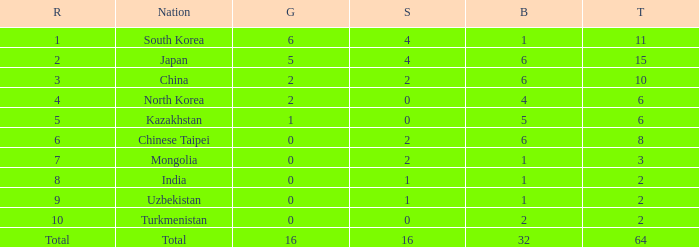How many Golds did Rank 10 get, with a Bronze larger than 2? 0.0. 